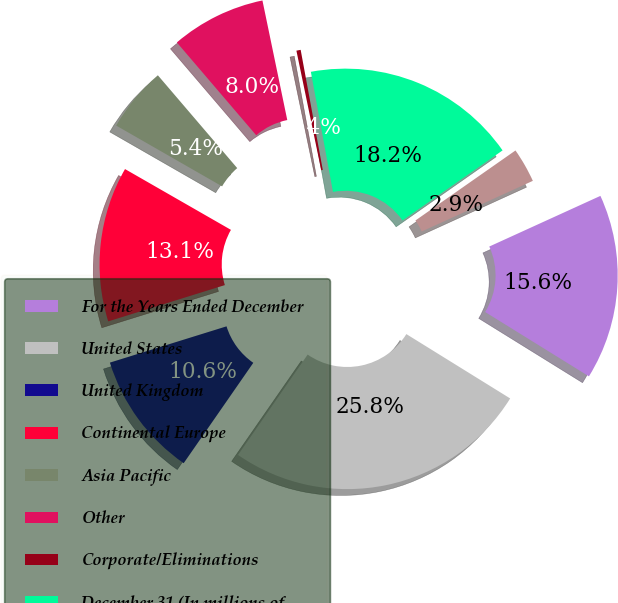<chart> <loc_0><loc_0><loc_500><loc_500><pie_chart><fcel>For the Years Ended December<fcel>United States<fcel>United Kingdom<fcel>Continental Europe<fcel>Asia Pacific<fcel>Other<fcel>Corporate/Eliminations<fcel>December 31 (In millions of<fcel>UnitedKingdom<nl><fcel>15.64%<fcel>25.82%<fcel>10.55%<fcel>13.09%<fcel>5.45%<fcel>8.0%<fcel>0.36%<fcel>18.18%<fcel>2.91%<nl></chart> 